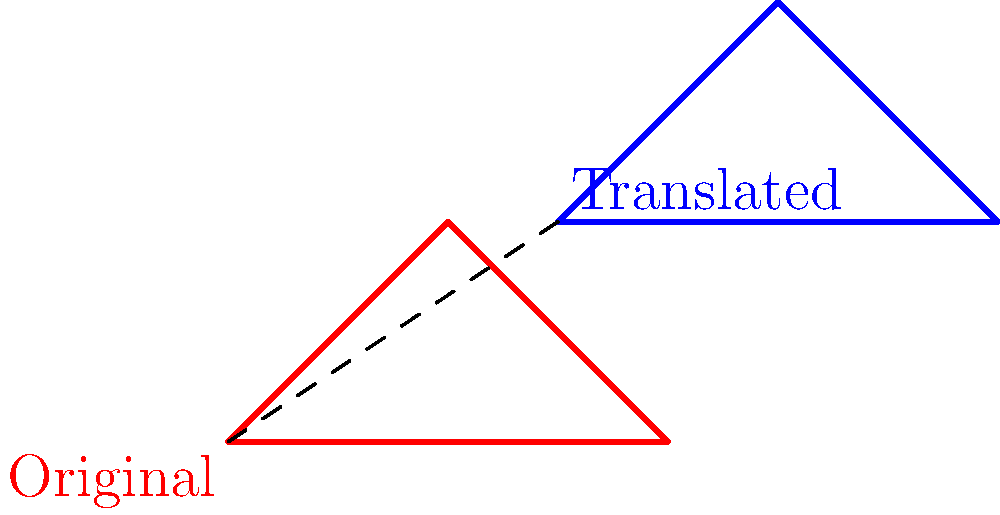In Swiss folk art, a traditional geometric pattern is represented by the red triangle. If this pattern is translated by the vector $\vec{v} = (3, 2)$, what are the coordinates of point A' (the translated version of point A) in the resulting blue triangle? To solve this problem, we'll follow these steps:

1. Identify the coordinates of point A in the original red triangle:
   Point A is located at $(-2, 0)$

2. Recall the translation vector:
   $\vec{v} = (3, 2)$

3. Apply the translation to point A:
   - To translate a point, we add the components of the translation vector to the coordinates of the original point.
   - New x-coordinate = Original x-coordinate + x-component of $\vec{v}$
   - New y-coordinate = Original y-coordinate + y-component of $\vec{v}$

4. Calculate the new coordinates:
   - A'_x = -2 + 3 = 1
   - A'_y = 0 + 2 = 2

5. Express the result as an ordered pair:
   A' = (1, 2)
Answer: (1, 2) 